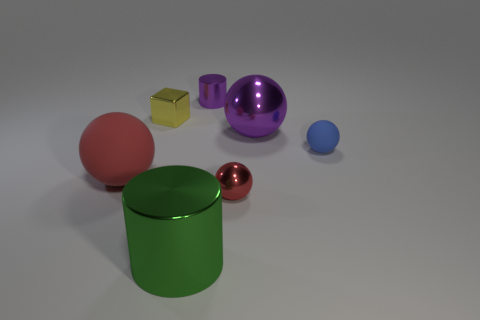Subtract all green cubes. How many red balls are left? 2 Subtract all red metal balls. How many balls are left? 3 Subtract all purple balls. How many balls are left? 3 Add 2 cubes. How many objects exist? 9 Subtract all gray balls. Subtract all yellow blocks. How many balls are left? 4 Subtract all balls. How many objects are left? 3 Subtract all tiny metallic blocks. Subtract all red rubber things. How many objects are left? 5 Add 1 yellow blocks. How many yellow blocks are left? 2 Add 3 big blue shiny cubes. How many big blue shiny cubes exist? 3 Subtract 0 gray blocks. How many objects are left? 7 